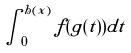<formula> <loc_0><loc_0><loc_500><loc_500>\int _ { 0 } ^ { h ( x ) } f ( g ( t ) ) d t</formula> 